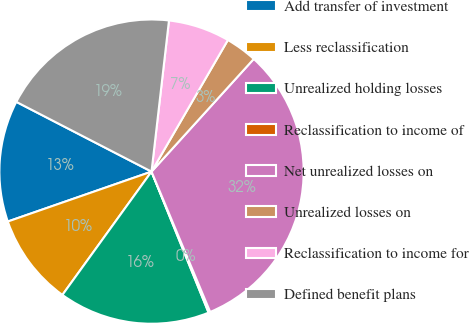Convert chart. <chart><loc_0><loc_0><loc_500><loc_500><pie_chart><fcel>Add transfer of investment<fcel>Less reclassification<fcel>Unrealized holding losses<fcel>Reclassification to income of<fcel>Net unrealized losses on<fcel>Unrealized losses on<fcel>Reclassification to income for<fcel>Defined benefit plans<nl><fcel>12.9%<fcel>9.72%<fcel>16.08%<fcel>0.18%<fcel>31.97%<fcel>3.36%<fcel>6.54%<fcel>19.25%<nl></chart> 